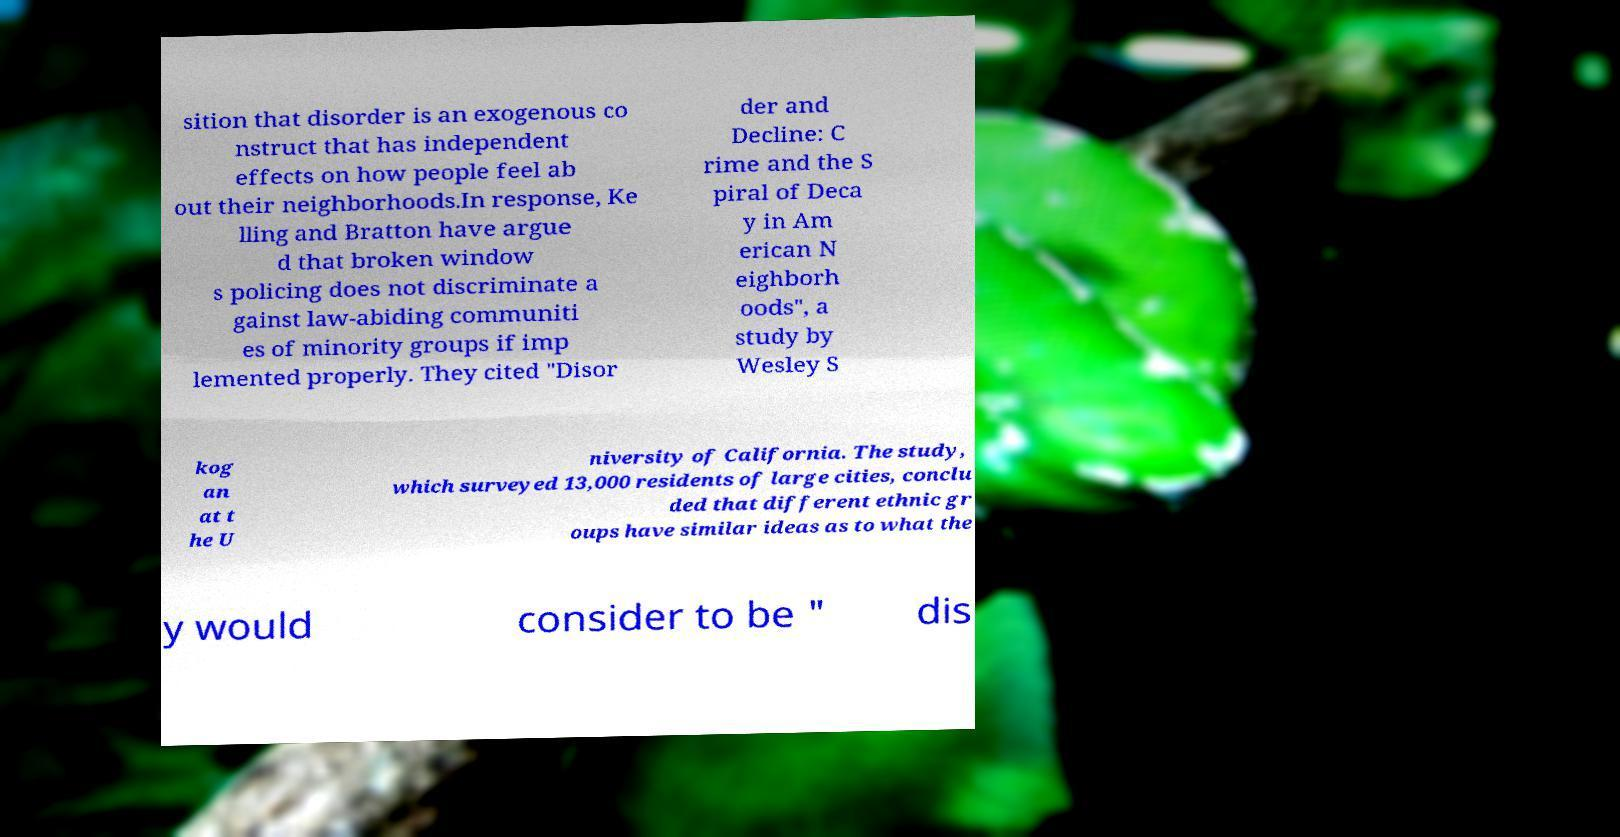There's text embedded in this image that I need extracted. Can you transcribe it verbatim? sition that disorder is an exogenous co nstruct that has independent effects on how people feel ab out their neighborhoods.In response, Ke lling and Bratton have argue d that broken window s policing does not discriminate a gainst law-abiding communiti es of minority groups if imp lemented properly. They cited "Disor der and Decline: C rime and the S piral of Deca y in Am erican N eighborh oods", a study by Wesley S kog an at t he U niversity of California. The study, which surveyed 13,000 residents of large cities, conclu ded that different ethnic gr oups have similar ideas as to what the y would consider to be " dis 